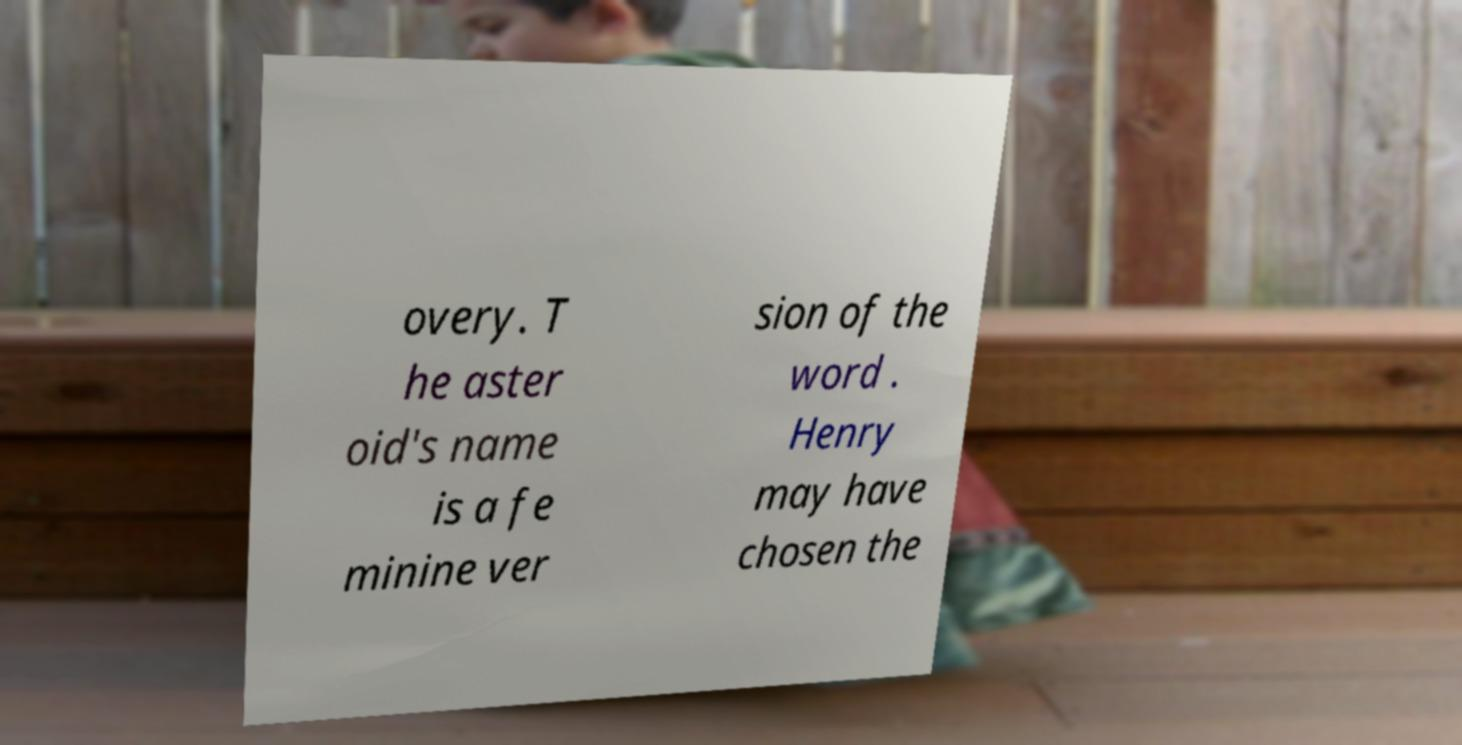Can you accurately transcribe the text from the provided image for me? overy. T he aster oid's name is a fe minine ver sion of the word . Henry may have chosen the 